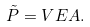Convert formula to latex. <formula><loc_0><loc_0><loc_500><loc_500>\tilde { P } = V E A .</formula> 